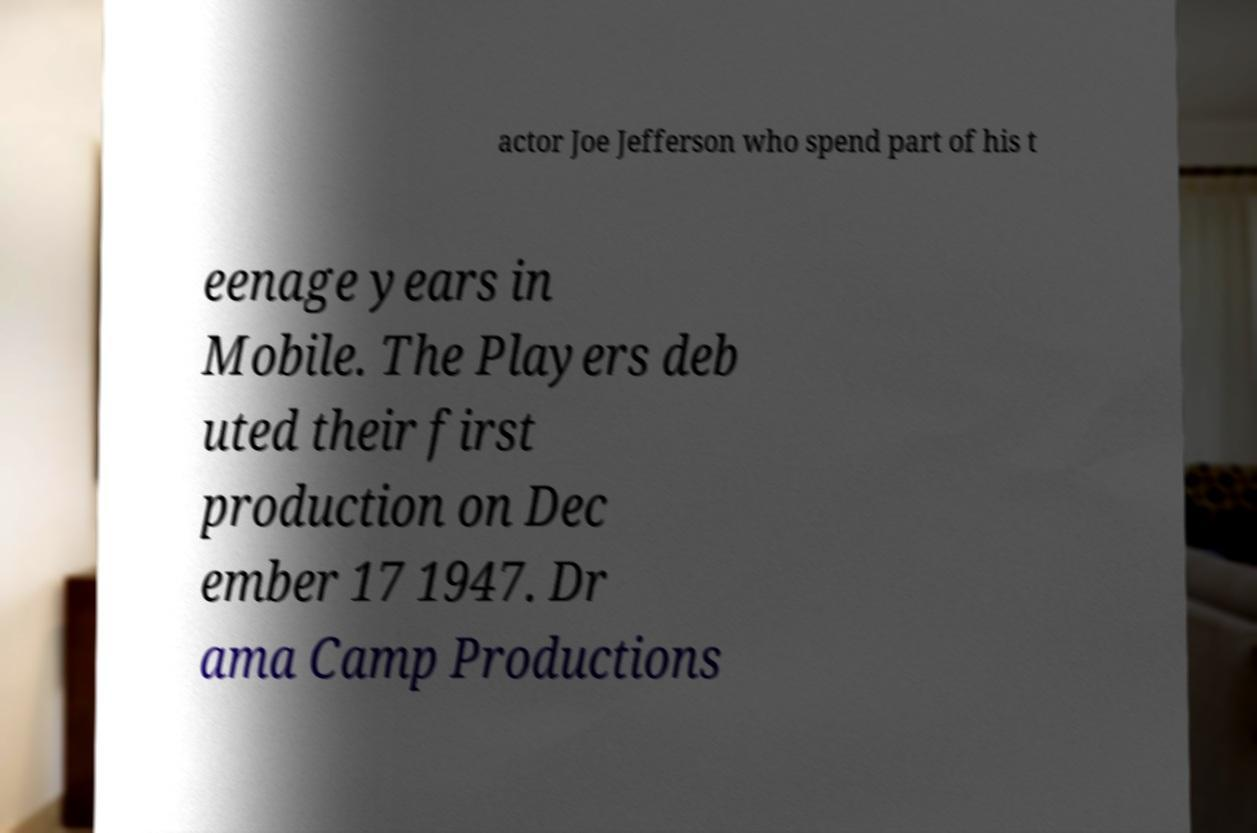Can you accurately transcribe the text from the provided image for me? actor Joe Jefferson who spend part of his t eenage years in Mobile. The Players deb uted their first production on Dec ember 17 1947. Dr ama Camp Productions 